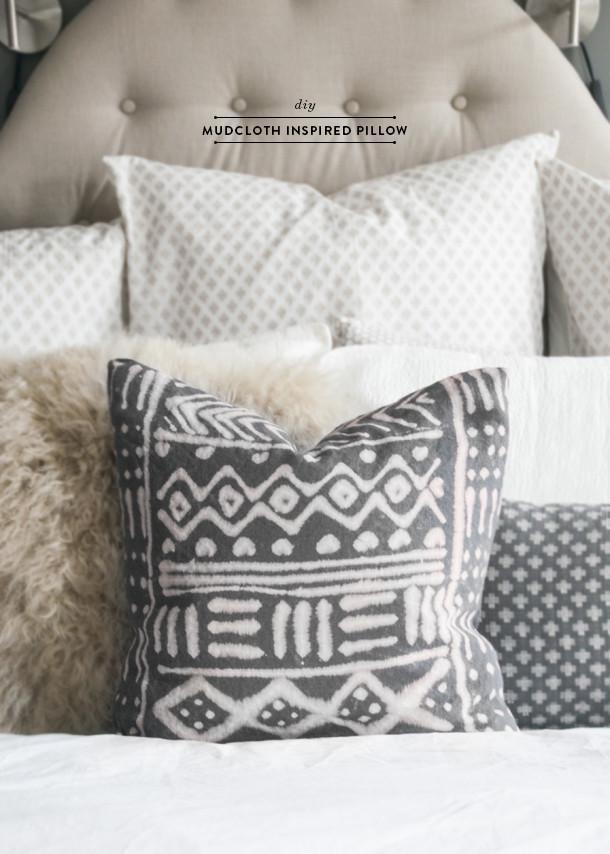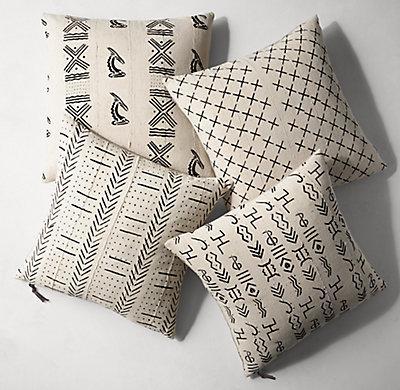The first image is the image on the left, the second image is the image on the right. For the images displayed, is the sentence "there is a bench in front of a window with a fringed blanket draped on it" factually correct? Answer yes or no. No. 